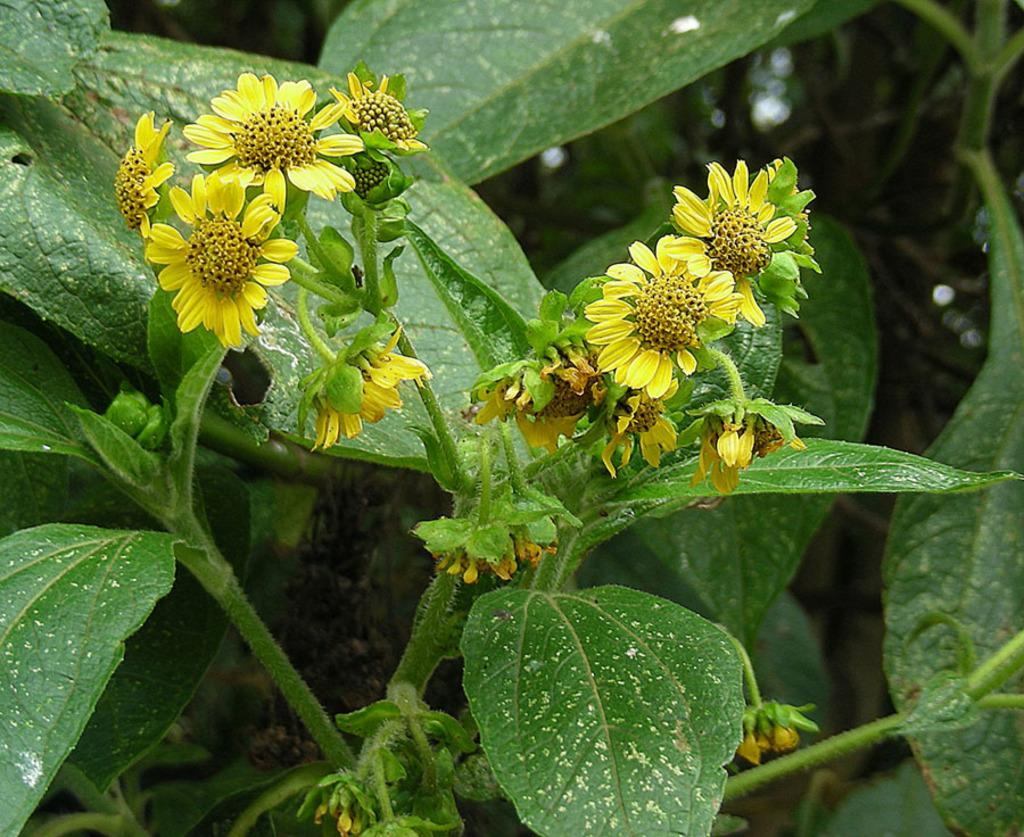What type of plant can be seen in the picture? There is a plant with flowers in the picture. Can you describe the background of the image? The background of the image is blurred. What type of house can be seen in the background of the image? There is no house visible in the image; the background is blurred. What liquid is being poured from the plant in the image? There is no liquid being poured from the plant in the image; it is a static image of a plant with flowers. 